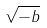Convert formula to latex. <formula><loc_0><loc_0><loc_500><loc_500>\sqrt { - b }</formula> 